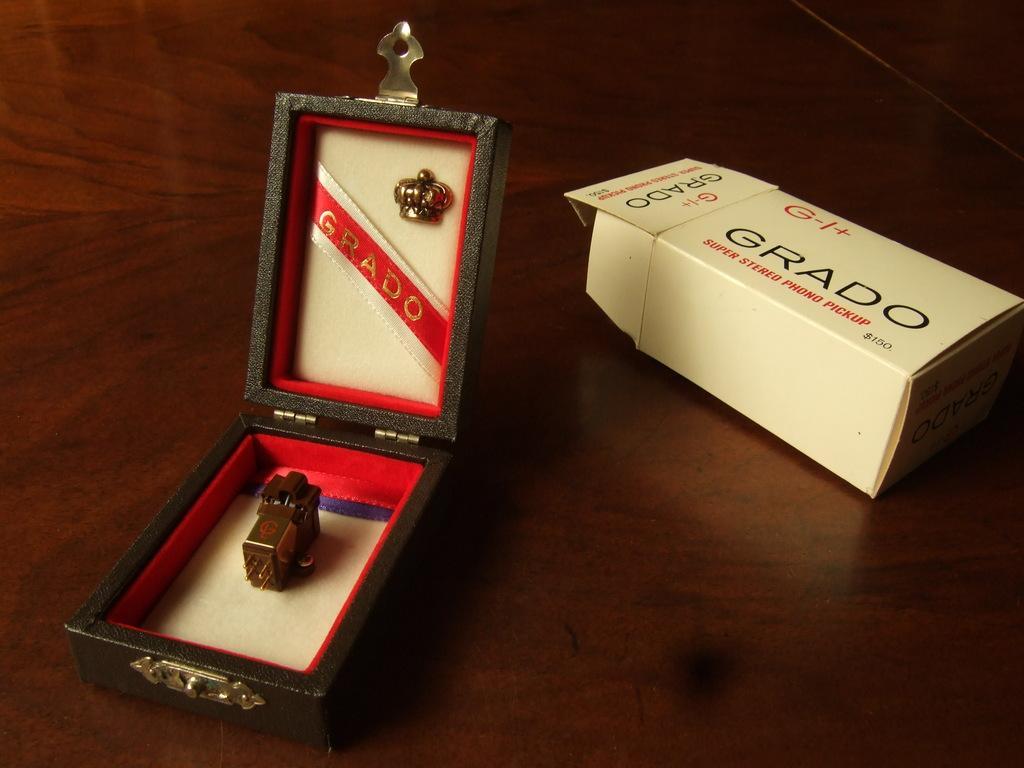In one or two sentences, can you explain what this image depicts? In this picture we can see two boxes, there is something present in this box, we can see some text on this box, at the bottom there is wooden surface. 